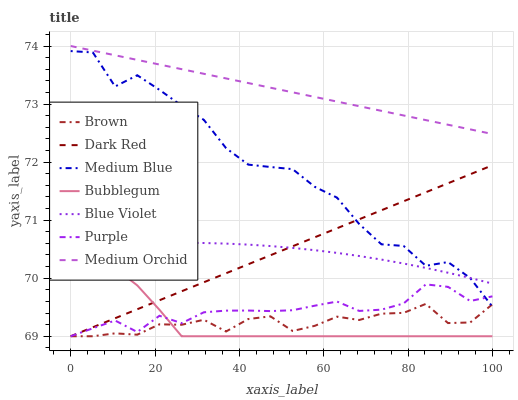Does Brown have the minimum area under the curve?
Answer yes or no. Yes. Does Medium Orchid have the maximum area under the curve?
Answer yes or no. Yes. Does Purple have the minimum area under the curve?
Answer yes or no. No. Does Purple have the maximum area under the curve?
Answer yes or no. No. Is Dark Red the smoothest?
Answer yes or no. Yes. Is Medium Blue the roughest?
Answer yes or no. Yes. Is Purple the smoothest?
Answer yes or no. No. Is Purple the roughest?
Answer yes or no. No. Does Medium Orchid have the lowest value?
Answer yes or no. No. Does Medium Orchid have the highest value?
Answer yes or no. Yes. Does Purple have the highest value?
Answer yes or no. No. Is Purple less than Medium Orchid?
Answer yes or no. Yes. Is Medium Orchid greater than Purple?
Answer yes or no. Yes. Does Purple intersect Medium Orchid?
Answer yes or no. No. 